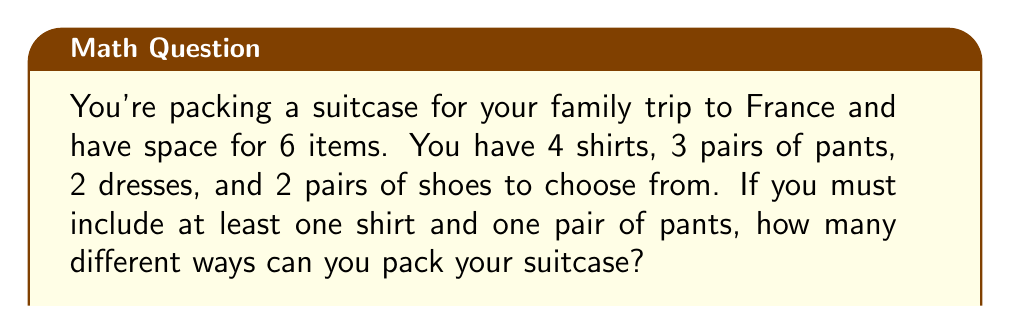Solve this math problem. Let's approach this step-by-step:

1) First, we need to ensure we have at least one shirt and one pair of pants. This leaves us with 4 more items to choose.

2) We can use the multiplication principle to solve this problem. We'll multiply the number of ways to choose each item:

   $$(4 \text{ shirts}) \times (3 \text{ pants}) \times (\text{ways to choose remaining 4 items})$$

3) For the remaining 4 items, we need to use the combination formula. We have 9 items left (3 shirts, 2 pants, 2 dresses, 2 shoes) and need to choose 4.

4) The combination formula is:

   $$\binom{n}{r} = \frac{n!}{r!(n-r)!}$$

   Where $n$ is the total number of items and $r$ is the number we're choosing.

5) In this case, $n = 9$ and $r = 4$:

   $$\binom{9}{4} = \frac{9!}{4!(9-4)!} = \frac{9!}{4!5!} = 126$$

6) Now, we can put it all together:

   $$4 \times 3 \times 126 = 1,512$$

Therefore, there are 1,512 different ways to pack the suitcase.
Answer: 1,512 